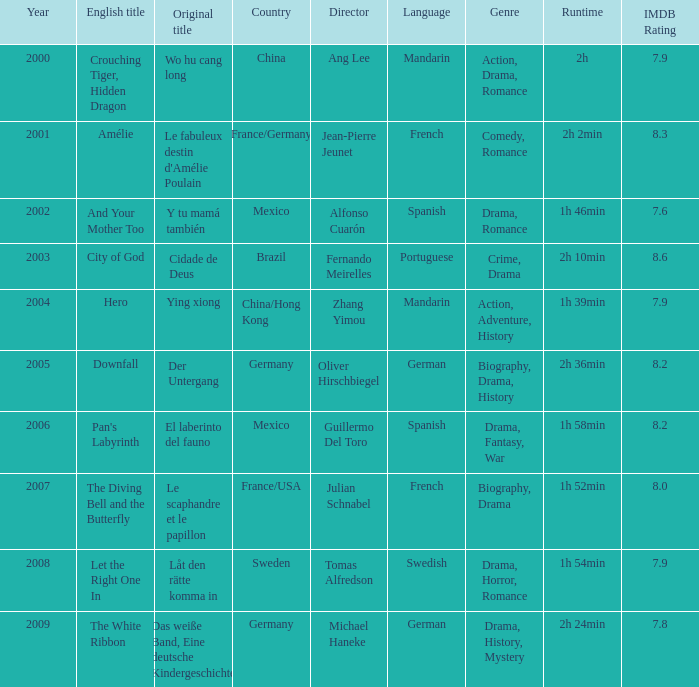Name the title of jean-pierre jeunet Amélie. 